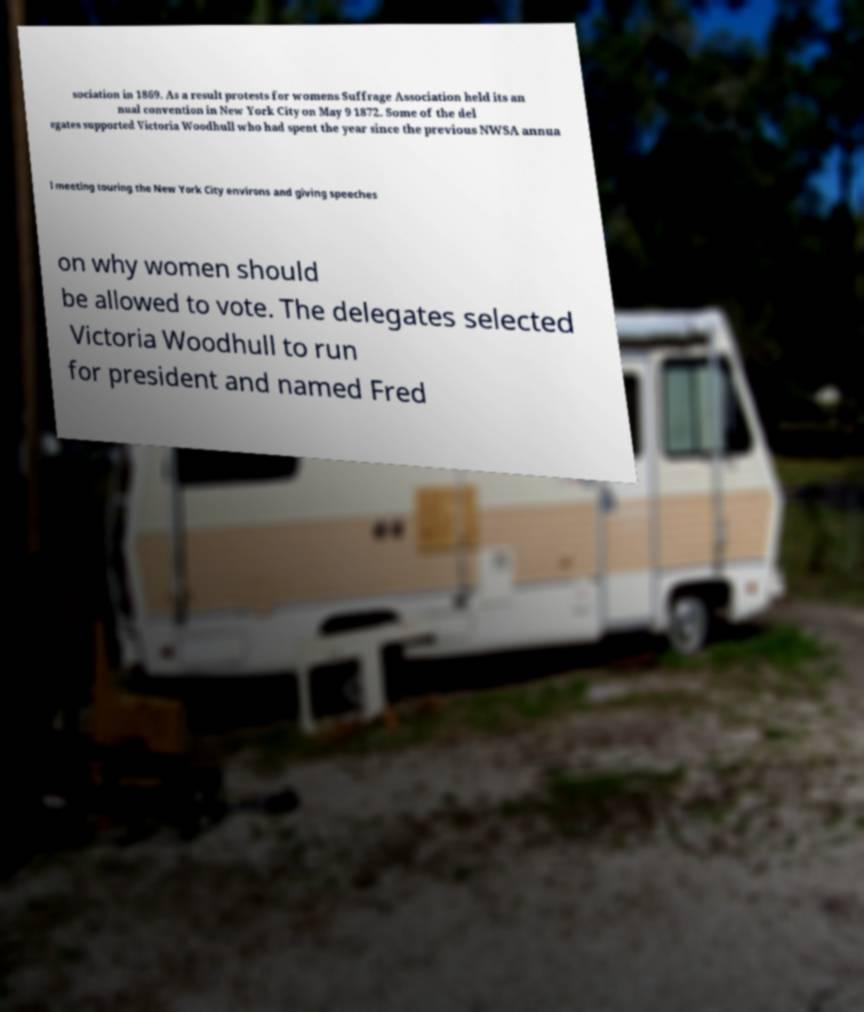There's text embedded in this image that I need extracted. Can you transcribe it verbatim? sociation in 1869. As a result protests for womens Suffrage Association held its an nual convention in New York City on May 9 1872. Some of the del egates supported Victoria Woodhull who had spent the year since the previous NWSA annua l meeting touring the New York City environs and giving speeches on why women should be allowed to vote. The delegates selected Victoria Woodhull to run for president and named Fred 